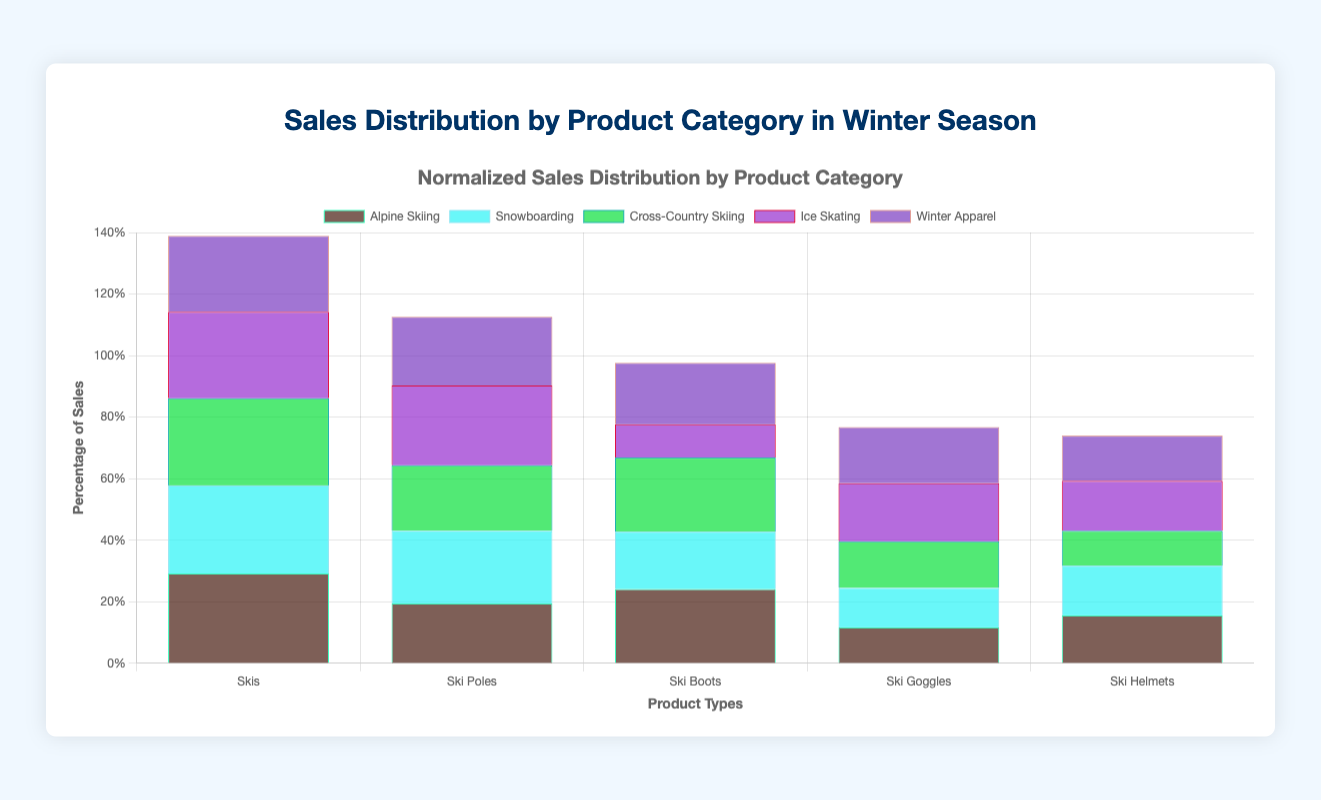What's the title of the figure? The title of the figure is provided at the top of the graph, above the chart area.
Answer: Sales Distribution by Product Category in Winter Season What are the categories listed on the x-axis? The x-axis represents the different product categories, which are products listed under Alpine Skiing, Snowboarding, Cross-Country Skiing, Ice Skating, and Winter Apparel. They include items such as Skis, Ski Poles, Ski Boots, etc.
Answer: Products like Skis, Ski Poles, Ski Boots, etc Which product category shows the highest percentage for any individual product? By observing each product's bar heights within each category, the highest bar represents the product with the highest percentage. In this case, it is the "Jackets" under "Winter Apparel."
Answer: Jackets in Winter Apparel For Alpine Skiing, which product has the lowest percentage of sales? By examining the bars for Alpine Skiing, we can compare their heights to find the shortest one, which corresponds to the "Ski Goggles."
Answer: Ski Goggles What is the combined sales percentage for Ski Boots and Ski Goggles in Alpine Skiing? First, find the percentage for Ski Boots and Ski Goggles by looking at their respective bars’ heights. Then, add these percentages together.
Answer: 30% (Ski Boots) + 14% (Ski Goggles) = 44% Compare the sales percentages of Ski Poles and Snowboard Boots. Which is higher and by how much? Examine the bars for Ski Poles (Alpine Skiing) and Snowboard Boots (Snowboarding) to determine their heights. Subtract the smaller percentage from the larger one to find the difference.
Answer: Ski Poles: 20%, Snowboard Boots: 24%, Difference: 4% Is there any product category that has all products with similar sales percentages? Investigate if any category has bars of roughly the same height, which would indicate similar percentages. The most uniform category in terms of percentage distribution is "Ice Skating."
Answer: Ice Skating What are the percentage sales of Thermal Wear in Winter Apparel? Identify the bar corresponding to Thermal Wear in Winter Apparel and note its height in percentage.
Answer: Approximately 17% Which product in Snowboarding has the highest percentage of sales? Within the Snowboarding category, find the tallest bar to identify the product with the highest sales percentage. In this case, it is "Snowboards."
Answer: Snowboards Between Cross-Country Poles and Cross-Country Boots, which has a higher percentage of sales? Compare the heights of the bars for Cross-Country Poles and Cross-Country Boots within the Cross-Country Skiing category.
Answer: Cross-Country Boots 